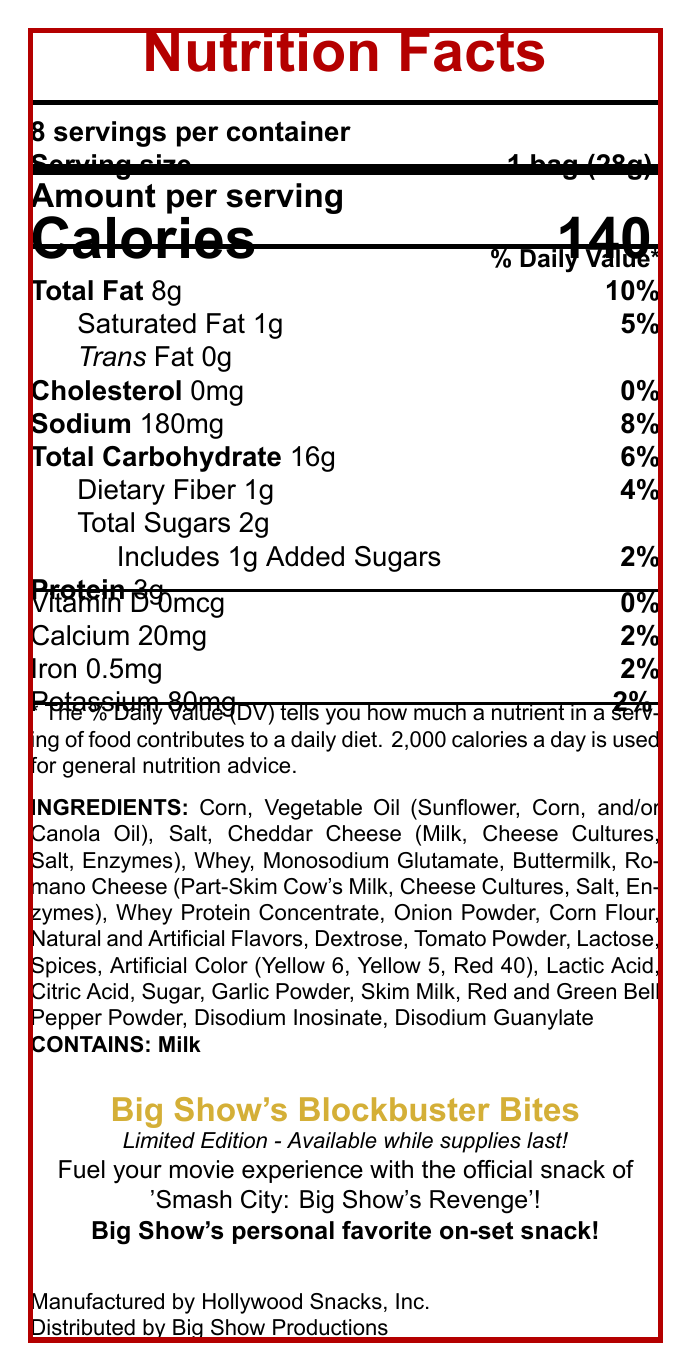What is the serving size for Big Show's Blockbuster Bites? The serving size is specified as "1 bag (28g)" in the document.
Answer: 1 bag (28g) How many calories are there per serving? The document lists the calorie count as 140 per serving.
Answer: 140 What is the total fat content in grams per serving? The document states that the total fat content is 8g per serving.
Answer: 8g What is the percentage of the daily value of sodium per serving? The daily value percentage for sodium is given as 8%.
Answer: 8% Which vitamin has no daily value percentage in Big Show's Blockbuster Bites? The document indicates that Vitamin D has a 0% daily value.
Answer: Vitamin D What is the amount of dietary fiber in Big Show's Blockbuster Bites? The dietary fiber amount is listed as 1g in the document.
Answer: 1g What is the amount of protein per serving? The document states that there are 3g of protein per serving.
Answer: 3g What ingredient is listed fourth in the ingredients section? The fourth ingredient listed is Cheddar Cheese (Milk, Cheese Cultures, Salt, Enzymes).
Answer: Cheddar Cheese (Milk, Cheese Cultures, Salt, Enzymes) What is the manufacturer's name? The manufacturer is indicated as Hollywood Snacks, Inc. in the document.
Answer: Hollywood Snacks, Inc. List one mineral included in the nutrition facts and its daily value percentage. The document lists Calcium with a daily value percentage of 2%.
Answer: Calcium, 2% How much added sugar does one serving contain? One serving contains 1g of added sugar.
Answer: 1g Does the product contain any trans fat? The document specifies that the product contains 0g of trans fat.
Answer: No A person is on a diet that limits sodium intake to 1,000mg per day. How many servings of Big Show's Blockbuster Bites can they consume without exceeding this limit? A. 4 servings B. 5 servings C. 6 servings D. 8 servings The sodium amount per serving is 180mg, so dividing 1,000mg by 180mg/serving equals about 5.55, so they can consume up to 5 servings without exceeding 1,000mg of sodium.
Answer: B Which of the following is not an ingredient in Big Show's Blockbuster Bites? A. Salt B. Whey C. Honey D. Tomato Powder The document lists all ingredients, and honey is not among them.
Answer: C Is "Smash City: Big Show's Revenge" the movie tie-in with the snack? The document mentions that "Smash City: Big Show's Revenge" is the movie tie-in.
Answer: Yes Which company's product distribution is mentioned in the document? The document states that the product is distributed by Big Show Productions.
Answer: Big Show Productions Summarize the details provided in the document about Big Show's Blockbuster Bites. This summary includes essential information about the product, its nutritional content, ingredients, manufacturing and distribution details, and its connection to the movie "Smash City: Big Show's Revenge," including the limited-edition status and endorsement by Big Show.
Answer: Big Show's Blockbuster Bites is a limited-edition snack food that ties in with the movie "Smash City: Big Show's Revenge." Each bag, weighing 28g, contains 140 calories and various nutrients such as fats, carbohydrates, protein, and vitamins. The ingredients include common snack components like corn, vegetable oils, different types of cheeses, spices, and artificial colors. The snack is manufactured by Hollywood Snacks, Inc. and distributed by Big Show Productions. The product contains milk and is endorsed as Big Show's personal favorite on-set snack. It is available for a limited time while supplies last. What is the main flavoring ingredient in Big Show's Blockbuster Bites? The document lists numerous ingredients, including various cheeses, natural and artificial flavors, and spices, but does not specify a single main flavoring ingredient.
Answer: Cannot be determined 